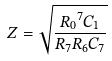Convert formula to latex. <formula><loc_0><loc_0><loc_500><loc_500>Z = \sqrt { \frac { { R _ { 0 } } ^ { 7 } C _ { 1 } } { R _ { 7 } R _ { 6 } C _ { 7 } } }</formula> 